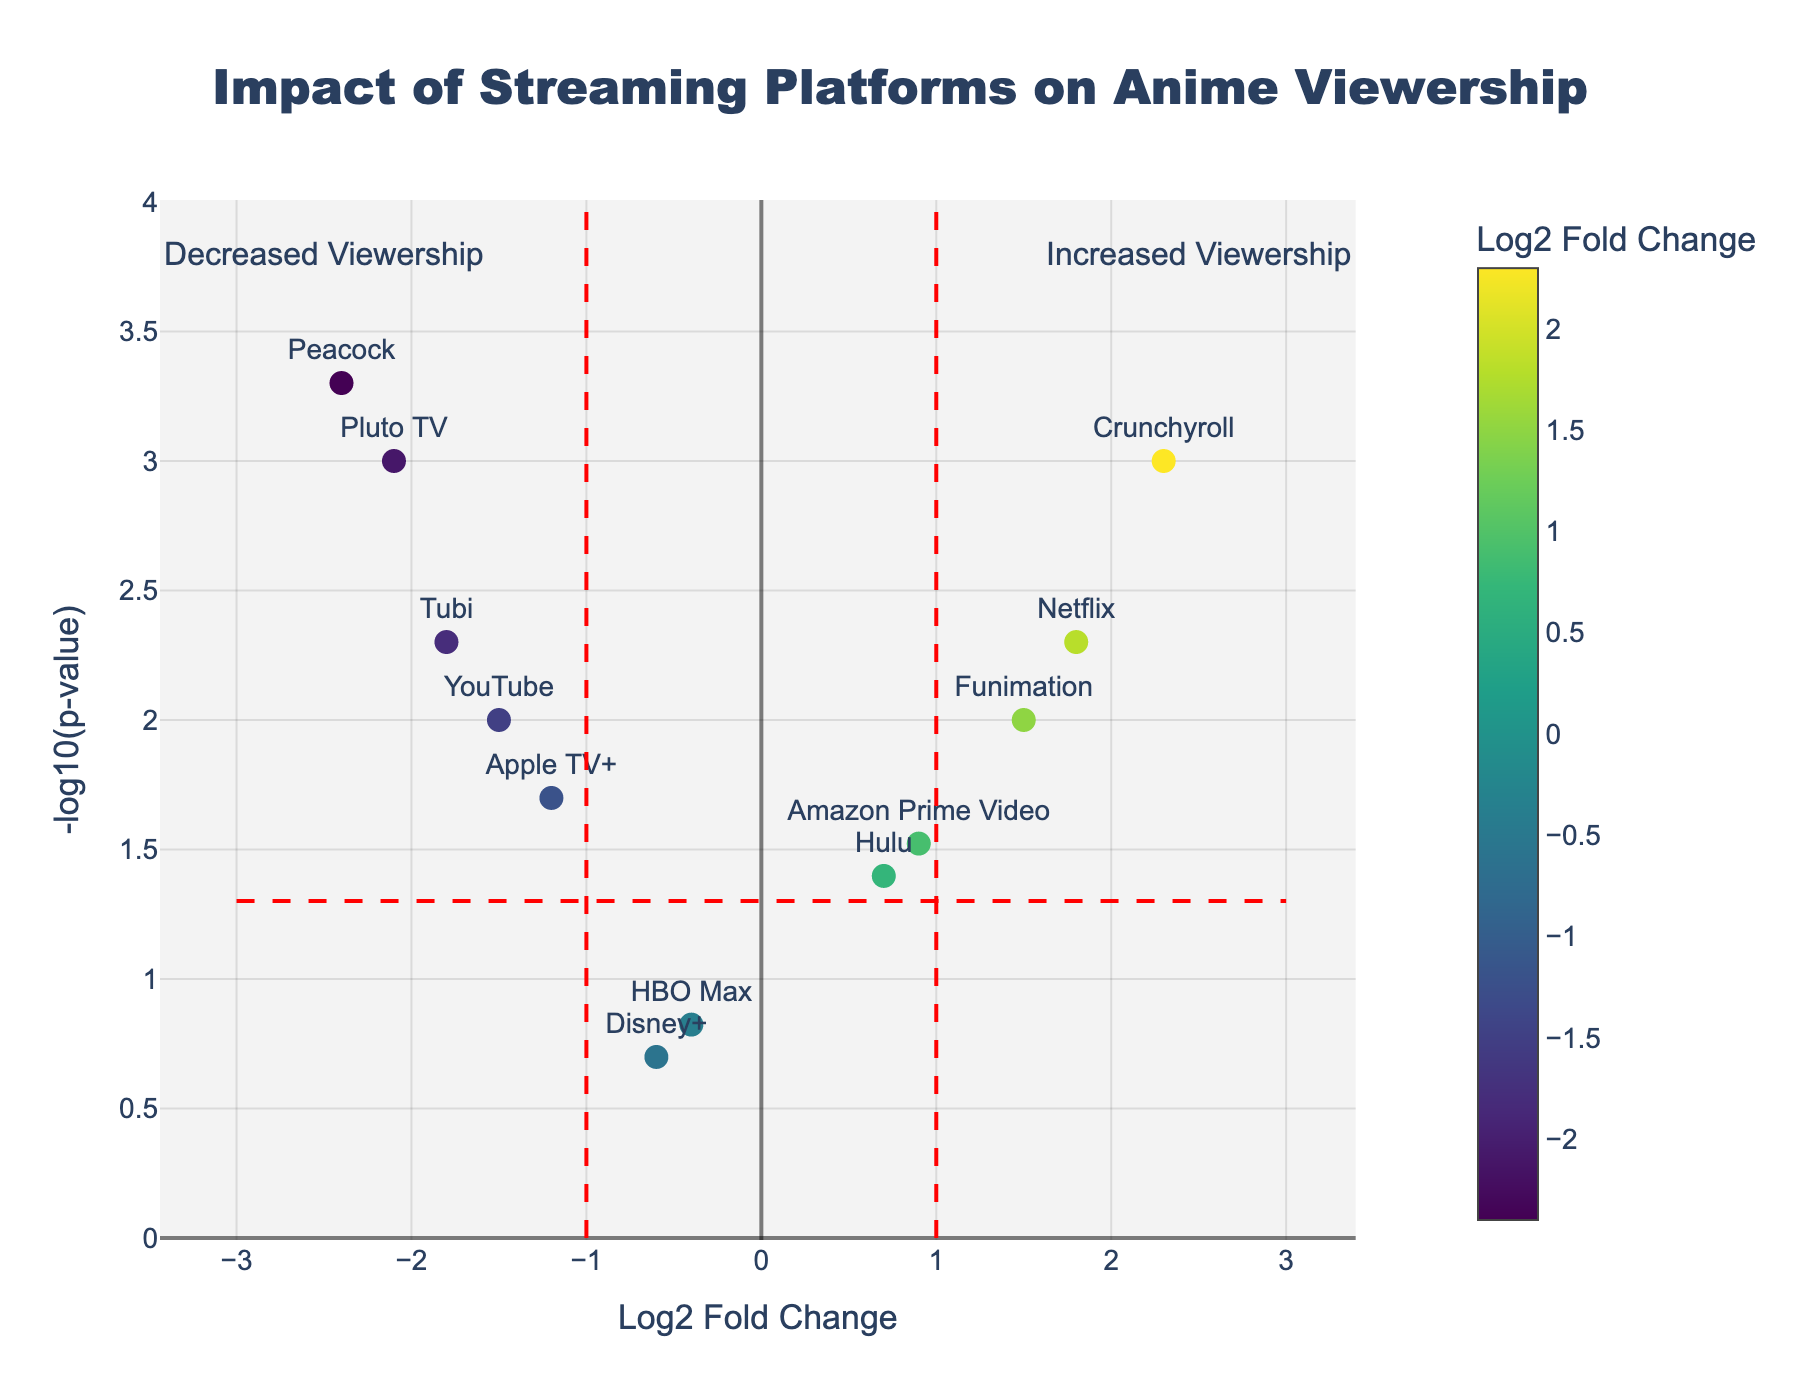What is the title of the plot? The title is usually located at the top of the plot. Here, it reads "Impact of Streaming Platforms on Anime Viewership".
Answer: Impact of Streaming Platforms on Anime Viewership Which streaming platform shows the highest increase in anime viewership? The platform with the highest Log2 Fold Change will show the highest increase. By examining the x-axis, Crunchyroll has the highest Log2 Fold Change value of 2.3.
Answer: Crunchyroll Which data points indicate a significant increase in viewership? Significant points fall outside the red dash lines at Log2 Fold Change of ±1 and have a -log10(p-value) greater than about 1.3 (p < 0.05). We see Crunchyroll, Netflix, and Funimation positioned higher and right of these thresholds.
Answer: Crunchyroll, Netflix, Funimation Which streaming platform indicates a significant decrease in anime viewership? Platforms with decreased viewership have negative Log2 Fold Changes less than -1 and p-values less than 0.05. By this criterion, Peacock, Pluto TV, and Tubi have significant decreases.
Answer: Peacock, Pluto TV, Tubi For which platform is the p-value not significant? Non-significant p-values are those greater than 0.05, which translates to a -log10(p-value) less than approximately 1.3. HBO Max and Disney+ are in this category.
Answer: HBO Max, Disney+ What is the Log2 Fold Change threshold indicated by the vertical red dash lines? The vertical dash lines mark the thresholds at ±1 Log2 Fold Change. This can be seen where the dashed lines intersect the x-axis at -1 and 1.
Answer: ±1 What does the horizontal red dash line represent? The horizontal red dash line denotes the p-value threshold of 0.05. This can be inferred from its position at a -log10(p-value) of approximately 1.3, as -log10(0.05) ≈ 1.3.
Answer: p-value = 0.05 Which platform has the lowest log2 fold change but is still statistically significant? The lowest Log2 Fold Change requires finding the most negative value with a -log10(p-value) greater than 1.3. Peacock shows the lowest value at -2.4 and is significant.
Answer: Peacock What can be inferred about Hulu's impact on anime viewership? Hulu’s Log2 Fold Change of 0.7 is positive, suggesting a slight increase in viewership. Its p-value is around 0.04, making it statistically significant but less impactful than platforms with higher Log2 Fold Changes.
Answer: Slight increase, statistically significant 